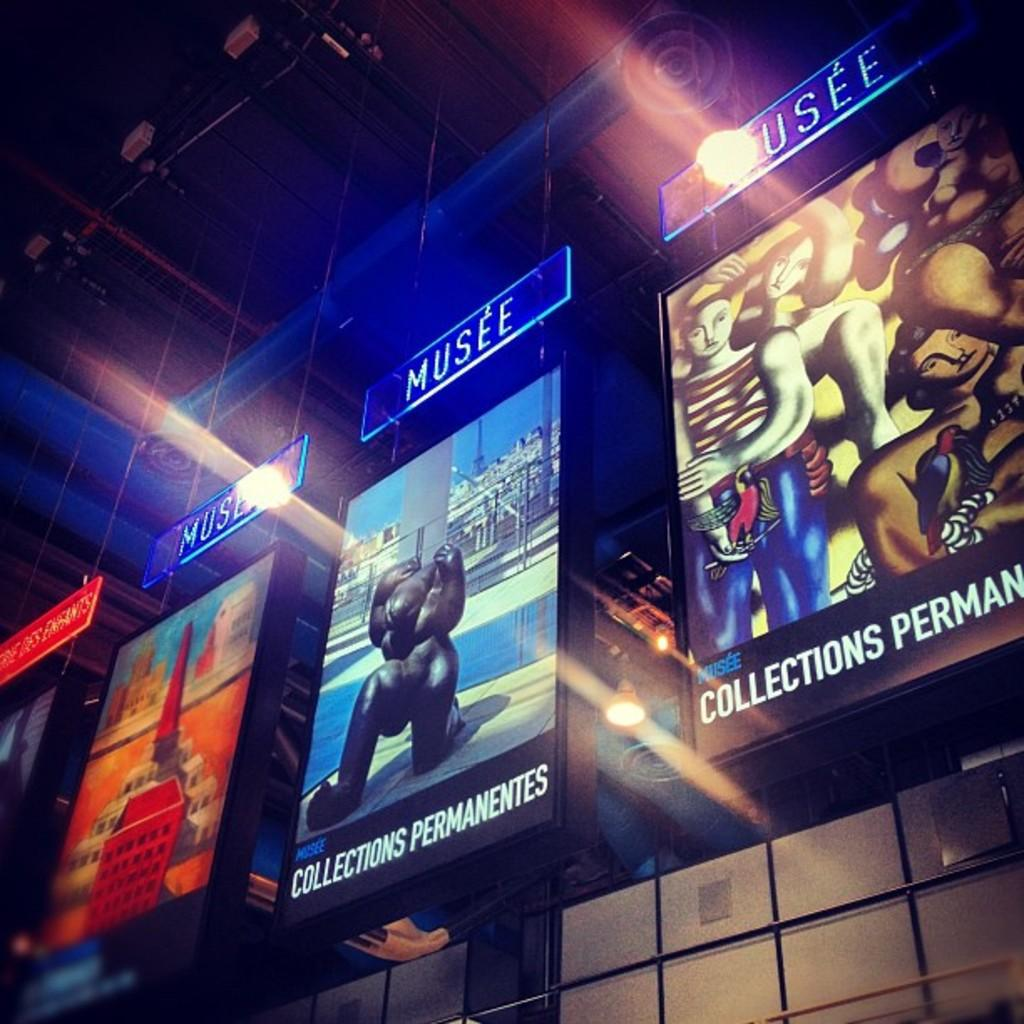<image>
Provide a brief description of the given image. Several large posters are hanging under signs that say Musee. 